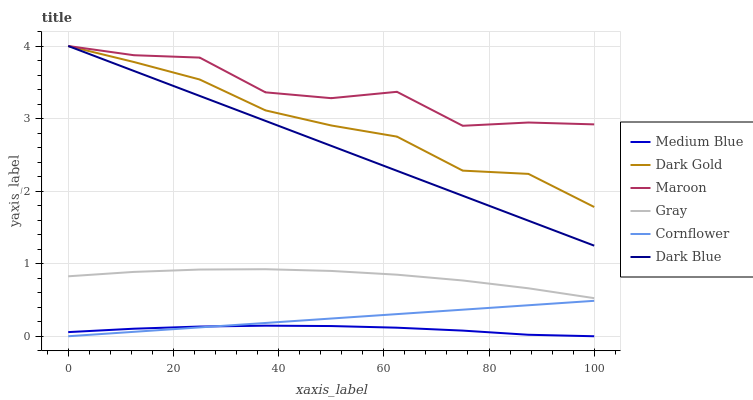Does Medium Blue have the minimum area under the curve?
Answer yes or no. Yes. Does Maroon have the maximum area under the curve?
Answer yes or no. Yes. Does Cornflower have the minimum area under the curve?
Answer yes or no. No. Does Cornflower have the maximum area under the curve?
Answer yes or no. No. Is Cornflower the smoothest?
Answer yes or no. Yes. Is Maroon the roughest?
Answer yes or no. Yes. Is Dark Gold the smoothest?
Answer yes or no. No. Is Dark Gold the roughest?
Answer yes or no. No. Does Cornflower have the lowest value?
Answer yes or no. Yes. Does Dark Gold have the lowest value?
Answer yes or no. No. Does Dark Blue have the highest value?
Answer yes or no. Yes. Does Cornflower have the highest value?
Answer yes or no. No. Is Cornflower less than Dark Blue?
Answer yes or no. Yes. Is Dark Gold greater than Cornflower?
Answer yes or no. Yes. Does Maroon intersect Dark Blue?
Answer yes or no. Yes. Is Maroon less than Dark Blue?
Answer yes or no. No. Is Maroon greater than Dark Blue?
Answer yes or no. No. Does Cornflower intersect Dark Blue?
Answer yes or no. No. 